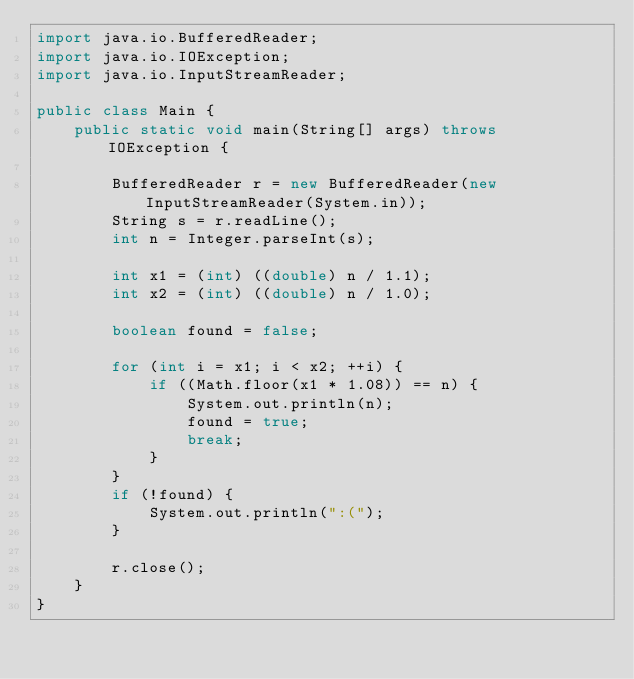<code> <loc_0><loc_0><loc_500><loc_500><_Java_>import java.io.BufferedReader;
import java.io.IOException;
import java.io.InputStreamReader;

public class Main {
	public static void main(String[] args) throws IOException {

		BufferedReader r = new BufferedReader(new InputStreamReader(System.in));
		String s = r.readLine();
		int n = Integer.parseInt(s);

		int x1 = (int) ((double) n / 1.1);
		int x2 = (int) ((double) n / 1.0);

		boolean found = false;

		for (int i = x1; i < x2; ++i) {
			if ((Math.floor(x1 * 1.08)) == n) {
				System.out.println(n);
				found = true;
				break;
			}
		}
		if (!found) {
			System.out.println(":(");
		}

		r.close();
	}
}</code> 